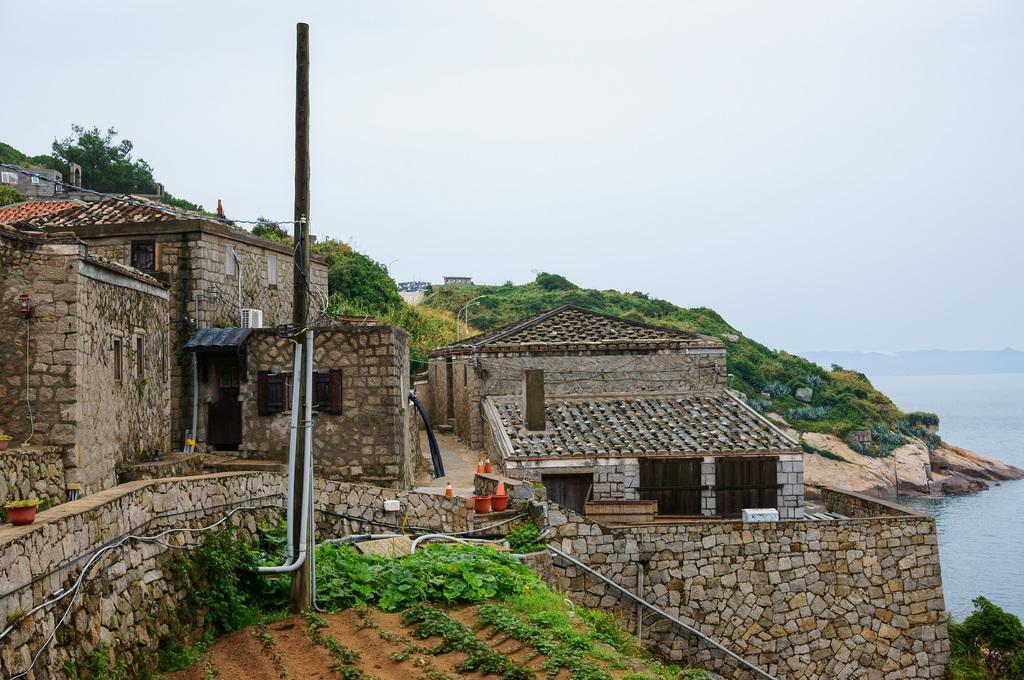How would you summarize this image in a sentence or two? In this picture I can see few buildings and plants in front. In the background I can see few trees and plants. I can also see the water and the sky and I can see a pole in the middle of this picture. 